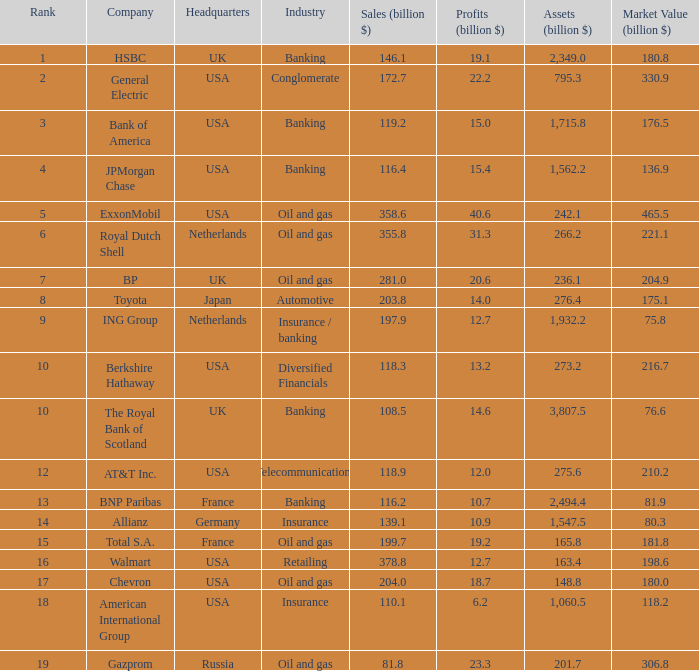What is the amount of profits in billions for companies with a market value of 204.9 billion?  20.6. 